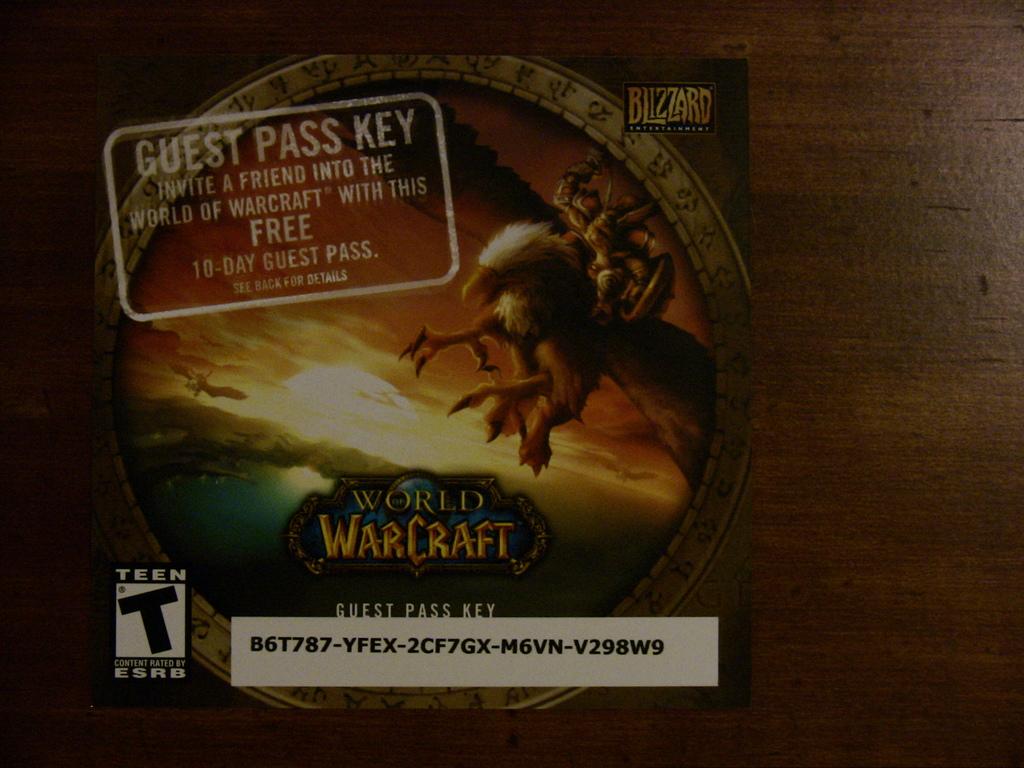What game is this for?
Keep it short and to the point. World of warcraft. How many days does the guest pass last?
Provide a short and direct response. 10. 